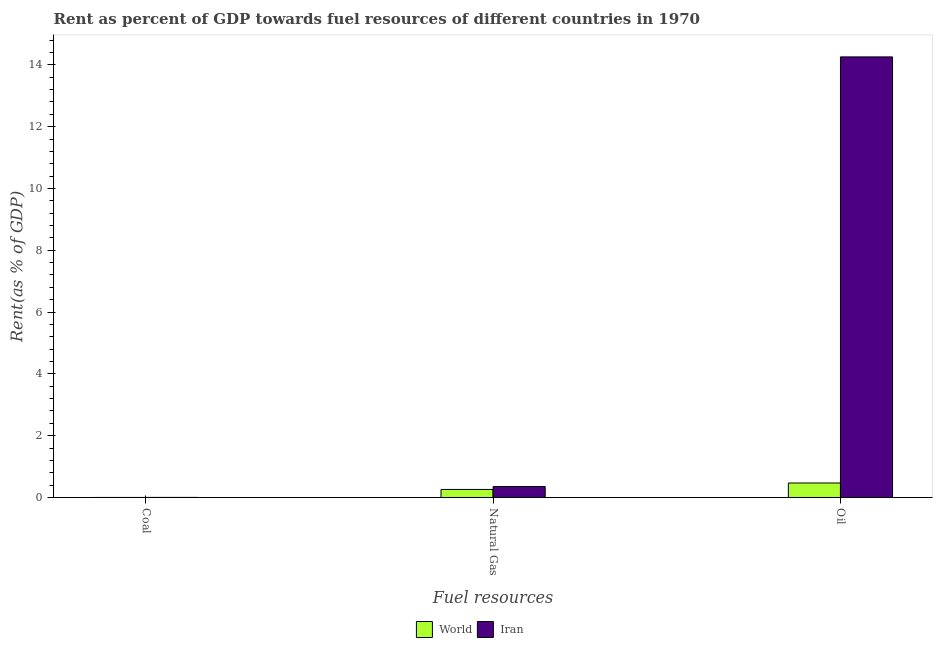Are the number of bars per tick equal to the number of legend labels?
Give a very brief answer. Yes. Are the number of bars on each tick of the X-axis equal?
Offer a very short reply. Yes. How many bars are there on the 2nd tick from the left?
Give a very brief answer. 2. What is the label of the 1st group of bars from the left?
Provide a short and direct response. Coal. What is the rent towards coal in World?
Your answer should be very brief. 0. Across all countries, what is the maximum rent towards coal?
Provide a short and direct response. 0. Across all countries, what is the minimum rent towards coal?
Offer a terse response. 0. In which country was the rent towards oil maximum?
Your response must be concise. Iran. In which country was the rent towards coal minimum?
Offer a very short reply. World. What is the total rent towards coal in the graph?
Offer a terse response. 0. What is the difference between the rent towards natural gas in Iran and that in World?
Provide a succinct answer. 0.09. What is the difference between the rent towards natural gas in World and the rent towards coal in Iran?
Your answer should be very brief. 0.26. What is the average rent towards natural gas per country?
Your response must be concise. 0.31. What is the difference between the rent towards natural gas and rent towards oil in Iran?
Offer a terse response. -13.9. In how many countries, is the rent towards natural gas greater than 2.8 %?
Make the answer very short. 0. What is the ratio of the rent towards oil in World to that in Iran?
Provide a short and direct response. 0.03. Is the difference between the rent towards natural gas in Iran and World greater than the difference between the rent towards oil in Iran and World?
Your response must be concise. No. What is the difference between the highest and the second highest rent towards coal?
Keep it short and to the point. 0. What is the difference between the highest and the lowest rent towards natural gas?
Make the answer very short. 0.09. What does the 1st bar from the right in Coal represents?
Give a very brief answer. Iran. Are all the bars in the graph horizontal?
Your answer should be compact. No. How many countries are there in the graph?
Your response must be concise. 2. Are the values on the major ticks of Y-axis written in scientific E-notation?
Give a very brief answer. No. Does the graph contain any zero values?
Keep it short and to the point. No. Does the graph contain grids?
Ensure brevity in your answer.  No. Where does the legend appear in the graph?
Provide a short and direct response. Bottom center. How are the legend labels stacked?
Provide a short and direct response. Horizontal. What is the title of the graph?
Your answer should be very brief. Rent as percent of GDP towards fuel resources of different countries in 1970. What is the label or title of the X-axis?
Ensure brevity in your answer.  Fuel resources. What is the label or title of the Y-axis?
Make the answer very short. Rent(as % of GDP). What is the Rent(as % of GDP) in World in Coal?
Provide a succinct answer. 0. What is the Rent(as % of GDP) in Iran in Coal?
Your answer should be compact. 0. What is the Rent(as % of GDP) of World in Natural Gas?
Your answer should be very brief. 0.26. What is the Rent(as % of GDP) in Iran in Natural Gas?
Make the answer very short. 0.35. What is the Rent(as % of GDP) in World in Oil?
Offer a terse response. 0.47. What is the Rent(as % of GDP) in Iran in Oil?
Make the answer very short. 14.26. Across all Fuel resources, what is the maximum Rent(as % of GDP) in World?
Offer a very short reply. 0.47. Across all Fuel resources, what is the maximum Rent(as % of GDP) in Iran?
Your answer should be very brief. 14.26. Across all Fuel resources, what is the minimum Rent(as % of GDP) of World?
Your answer should be very brief. 0. Across all Fuel resources, what is the minimum Rent(as % of GDP) in Iran?
Provide a succinct answer. 0. What is the total Rent(as % of GDP) in World in the graph?
Your answer should be very brief. 0.73. What is the total Rent(as % of GDP) of Iran in the graph?
Make the answer very short. 14.61. What is the difference between the Rent(as % of GDP) in World in Coal and that in Natural Gas?
Your response must be concise. -0.26. What is the difference between the Rent(as % of GDP) of Iran in Coal and that in Natural Gas?
Provide a succinct answer. -0.35. What is the difference between the Rent(as % of GDP) in World in Coal and that in Oil?
Your answer should be very brief. -0.47. What is the difference between the Rent(as % of GDP) in Iran in Coal and that in Oil?
Provide a short and direct response. -14.25. What is the difference between the Rent(as % of GDP) of World in Natural Gas and that in Oil?
Your answer should be compact. -0.21. What is the difference between the Rent(as % of GDP) in Iran in Natural Gas and that in Oil?
Your answer should be very brief. -13.9. What is the difference between the Rent(as % of GDP) of World in Coal and the Rent(as % of GDP) of Iran in Natural Gas?
Your answer should be compact. -0.35. What is the difference between the Rent(as % of GDP) of World in Coal and the Rent(as % of GDP) of Iran in Oil?
Offer a terse response. -14.26. What is the difference between the Rent(as % of GDP) in World in Natural Gas and the Rent(as % of GDP) in Iran in Oil?
Your answer should be compact. -14. What is the average Rent(as % of GDP) in World per Fuel resources?
Make the answer very short. 0.24. What is the average Rent(as % of GDP) in Iran per Fuel resources?
Give a very brief answer. 4.87. What is the difference between the Rent(as % of GDP) of World and Rent(as % of GDP) of Iran in Coal?
Offer a very short reply. -0. What is the difference between the Rent(as % of GDP) of World and Rent(as % of GDP) of Iran in Natural Gas?
Make the answer very short. -0.09. What is the difference between the Rent(as % of GDP) in World and Rent(as % of GDP) in Iran in Oil?
Make the answer very short. -13.79. What is the ratio of the Rent(as % of GDP) in World in Coal to that in Natural Gas?
Make the answer very short. 0. What is the ratio of the Rent(as % of GDP) of Iran in Coal to that in Natural Gas?
Offer a very short reply. 0.01. What is the ratio of the Rent(as % of GDP) of World in Coal to that in Oil?
Your response must be concise. 0. What is the ratio of the Rent(as % of GDP) in World in Natural Gas to that in Oil?
Provide a short and direct response. 0.56. What is the ratio of the Rent(as % of GDP) in Iran in Natural Gas to that in Oil?
Offer a terse response. 0.02. What is the difference between the highest and the second highest Rent(as % of GDP) of World?
Give a very brief answer. 0.21. What is the difference between the highest and the second highest Rent(as % of GDP) in Iran?
Give a very brief answer. 13.9. What is the difference between the highest and the lowest Rent(as % of GDP) of World?
Your response must be concise. 0.47. What is the difference between the highest and the lowest Rent(as % of GDP) of Iran?
Offer a very short reply. 14.25. 